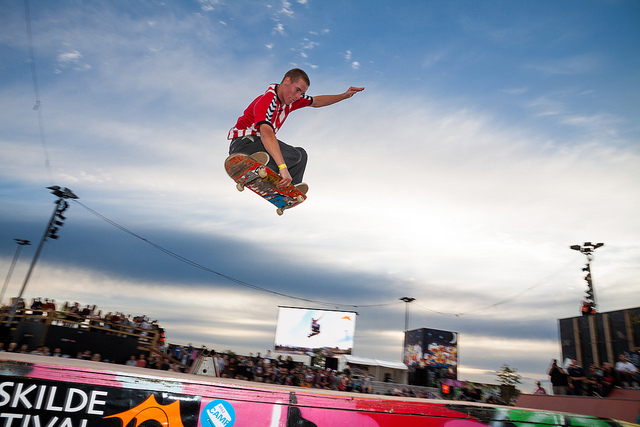What event might this image have been taken at? The image appears to have been taken at a skateboarding event or competition, possibly during a festival given the crowd and the banner in the background. The Roskilde Festival, mentioned in the corner, suggests it's a prominent event known for hosting various activities, including skateboarding. 